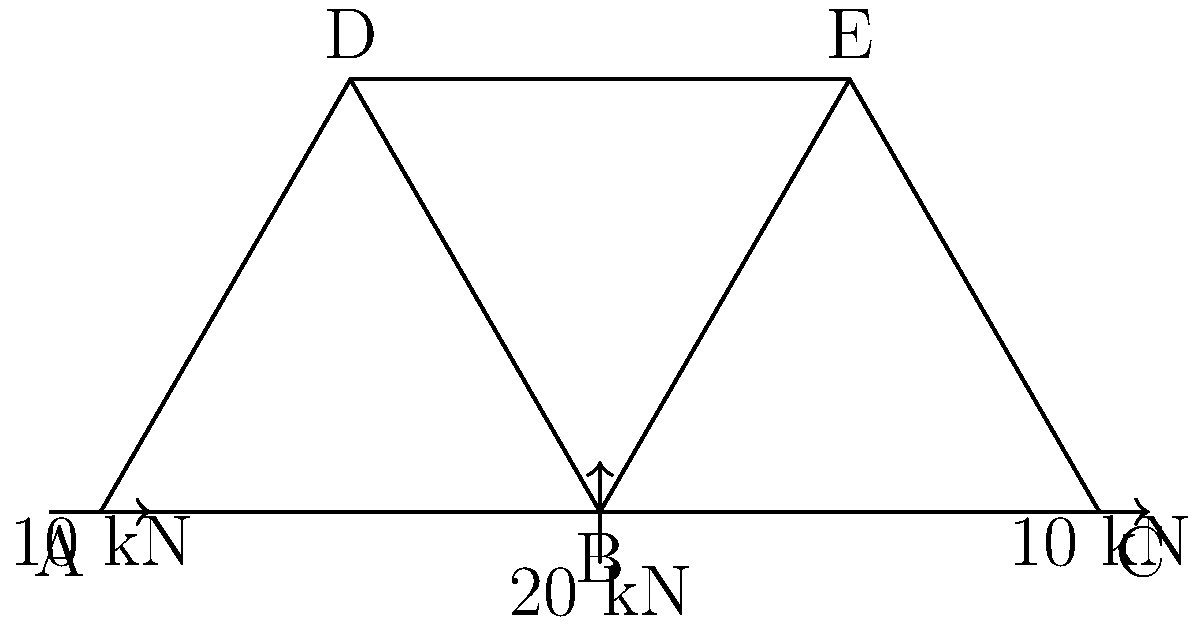Given the truss diagram above, where two 10 kN horizontal forces are applied at nodes A and C, and a 20 kN vertical force is applied at node B, determine the force in member BE. Assume all joints are pin connections and the truss is in static equilibrium. Express your answer in kN, indicating tension as positive and compression as negative. To solve this problem, we'll use the method of joints, focusing on joint B:

1) First, we need to determine the reaction forces at the supports. Due to symmetry, we can deduce that:
   - Vertical reaction at A = Vertical reaction at C = 10 kN (upward)
   - Horizontal reactions are zero due to the balanced horizontal forces

2) Now, let's analyze joint B:
   - We know the external force of 20 kN downward
   - We need to find the forces in members BA, BD, and BE

3) Due to symmetry, we know that forces in BA and BC are equal, and forces in BD and BE are equal

4) Let's denote the force in BE as $F_{BE}$

5) Writing the equilibrium equations for joint B:
   Vertical: $2F_{BA}\sin60° - 20 = 0$
   Horizontal: $2F_{BE}\cos30° + F_{BA}\cos60° = 0$

6) From the vertical equation:
   $2F_{BA}\cdot\frac{\sqrt{3}}{2} = 20$
   $F_{BA} = \frac{20}{\sqrt{3}} \approx 11.55$ kN (compression)

7) Substituting this into the horizontal equation:
   $2F_{BE}\cdot\frac{\sqrt{3}}{2} + 11.55\cdot\frac{1}{2} = 0$
   $F_{BE}\sqrt{3} + 5.775 = 0$
   $F_{BE} = -\frac{5.775}{\sqrt{3}} \approx -3.33$ kN

8) The negative sign indicates that member BE is in compression.
Answer: -3.33 kN 